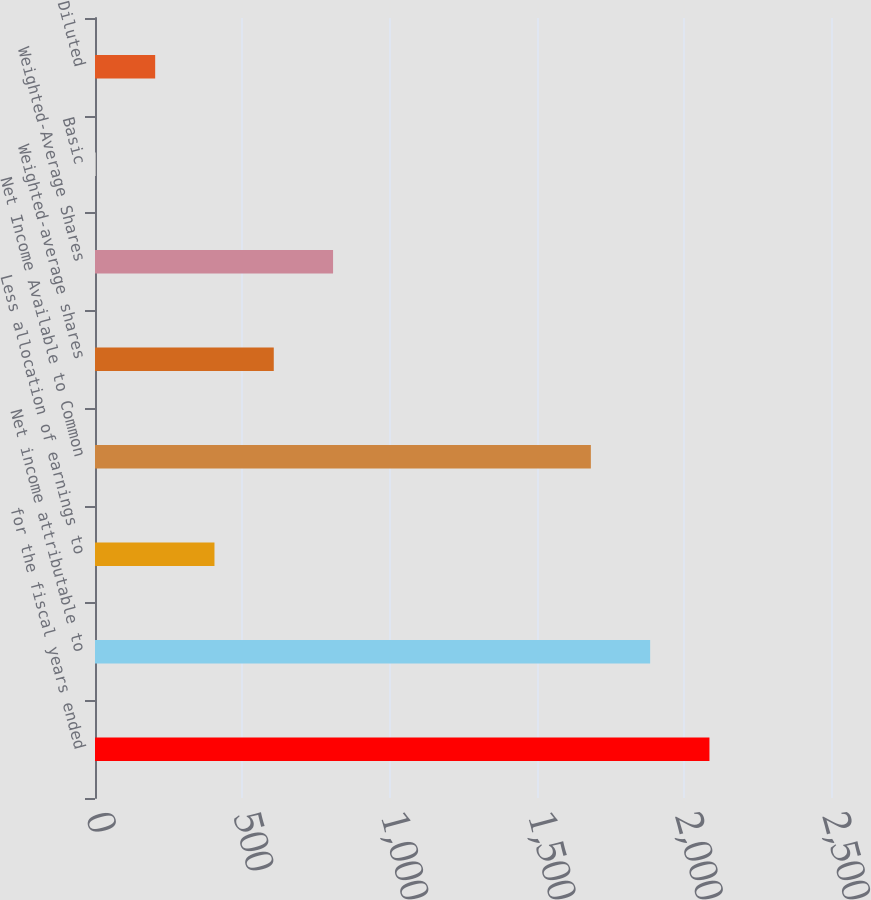<chart> <loc_0><loc_0><loc_500><loc_500><bar_chart><fcel>for the fiscal years ended<fcel>Net income attributable to<fcel>Less allocation of earnings to<fcel>Net Income Available to Common<fcel>Weighted-average shares<fcel>Weighted-Average Shares<fcel>Basic<fcel>Diluted<nl><fcel>2087.1<fcel>1885.7<fcel>405.81<fcel>1684.3<fcel>607.21<fcel>808.61<fcel>3.01<fcel>204.41<nl></chart> 